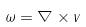<formula> <loc_0><loc_0><loc_500><loc_500>\omega = \nabla \times v</formula> 